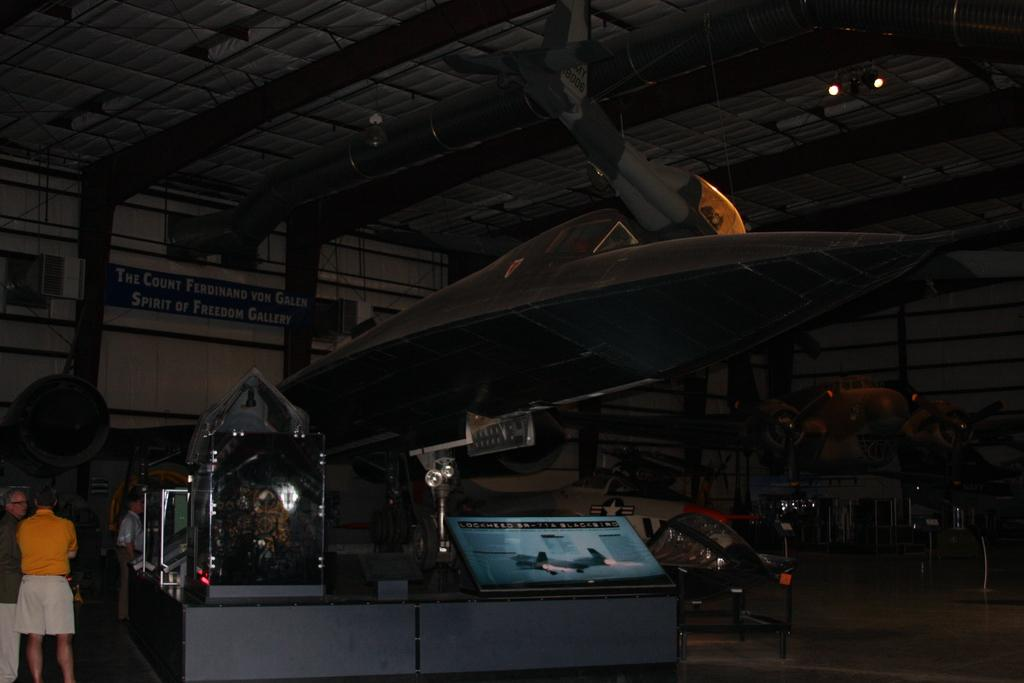What is the main subject of the picture? The main subject of the picture is an aircraft. Can you describe the people in the picture? There are two persons standing on the left side of the picture. What object can be seen in the picture besides the aircraft and people? There is a board in the picture. What can be seen at the top of the picture? There are two lights at the top of the picture. What type of popcorn is being served in the picture? There is no popcorn present in the picture; it features an aircraft and people standing nearby. What time of day is depicted in the picture, based on the hour? The provided facts do not mention the time of day or any specific hour, so it cannot be determined from the image. 